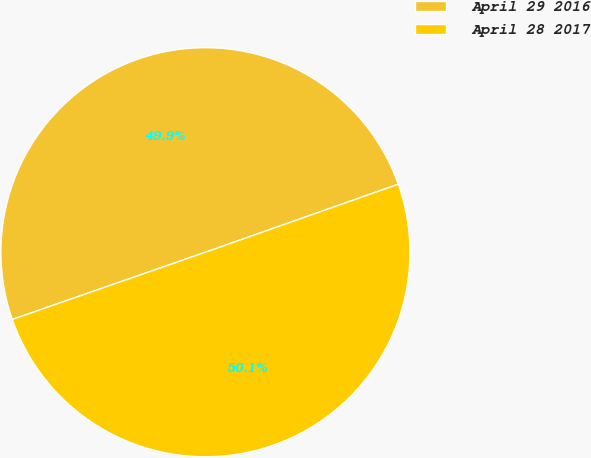<chart> <loc_0><loc_0><loc_500><loc_500><pie_chart><fcel>April 29 2016<fcel>April 28 2017<nl><fcel>49.94%<fcel>50.06%<nl></chart> 